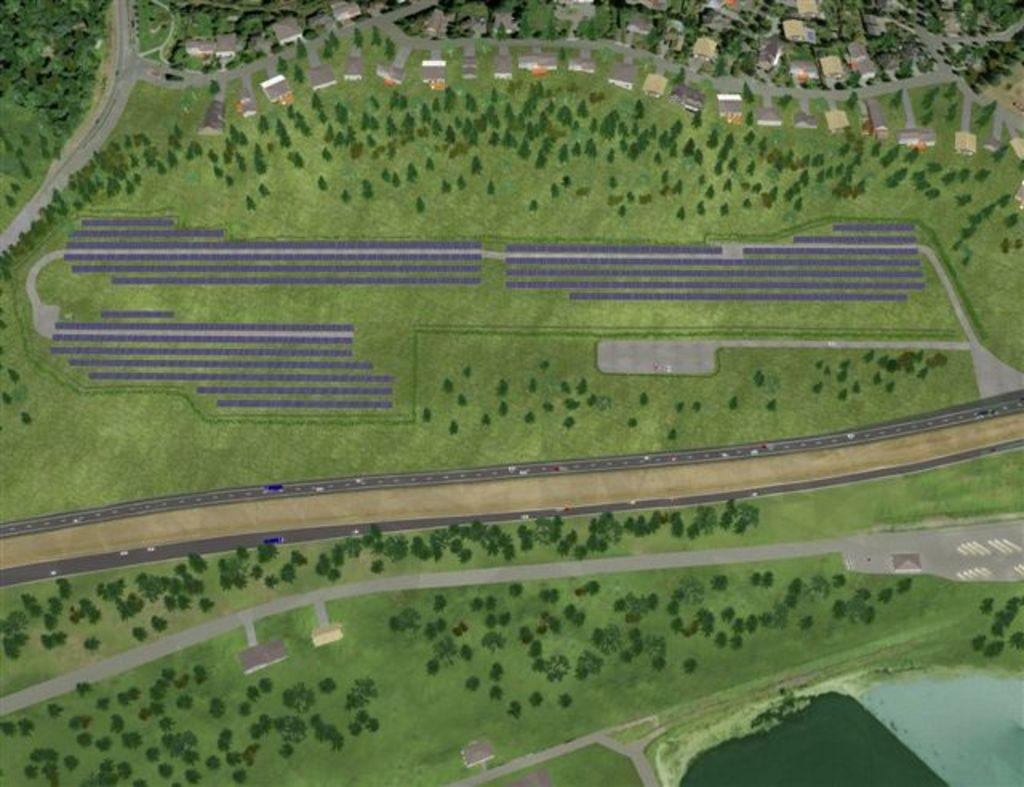What type of surface is visible from an aerial view in the image? The image shows an aerial view of a grass surface. What natural elements can be seen in the image? There are trees visible in the image. What man-made structures are present in the image? Houses are present in the image. What type of terrain feature can be seen in the image? There is water visible in the image. What type of transportation infrastructure is present in the image? Roads are present in the image. What type of clover is growing on the tooth in the image? There is no tooth or clover present in the image. What type of cloth is draped over the houses in the image? There is no cloth draped over the houses in the image. 